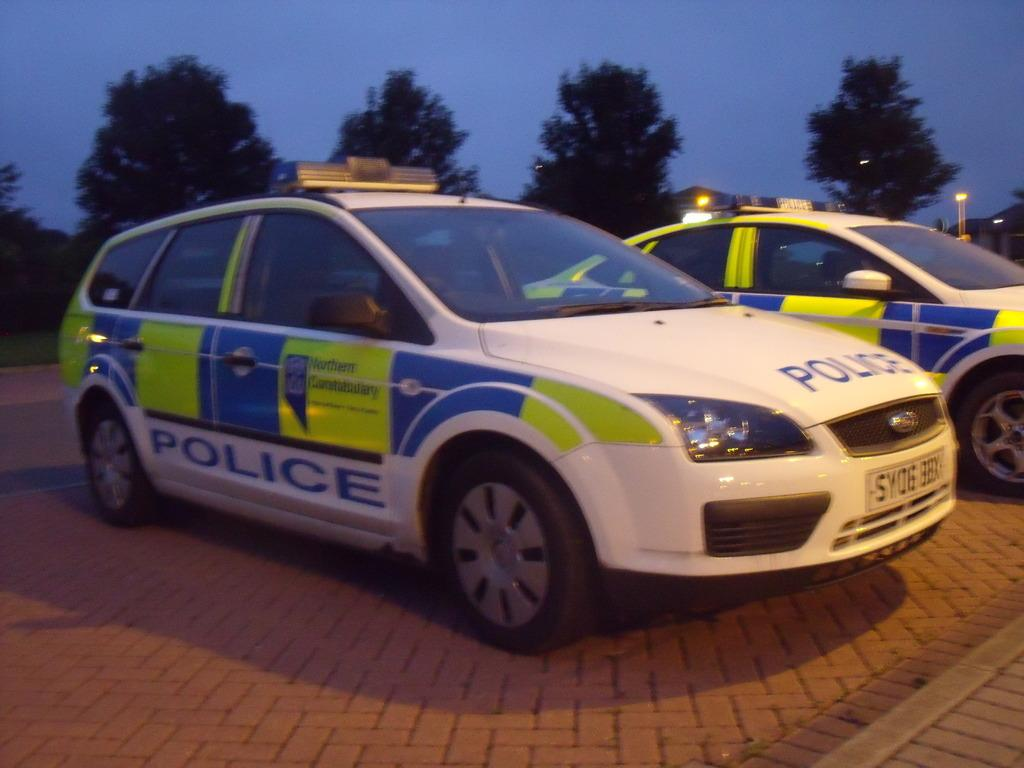What type of vehicles can be seen in the image? There are cars in the image. What type of natural vegetation is visible in the background of the image? There are trees in the background of the image. What is the condition of the sky in the image? The sky is clear in the image. What type of rice is being cooked in the image? There is no rice present in the image. Where is the playground located in the image? There is no playground present in the image. What type of wax is being used to create a sculpture in the image? There is no wax or sculpture present in the image. 